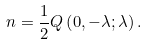Convert formula to latex. <formula><loc_0><loc_0><loc_500><loc_500>n = \frac { 1 } { 2 } Q \left ( 0 , - \lambda ; \lambda \right ) .</formula> 